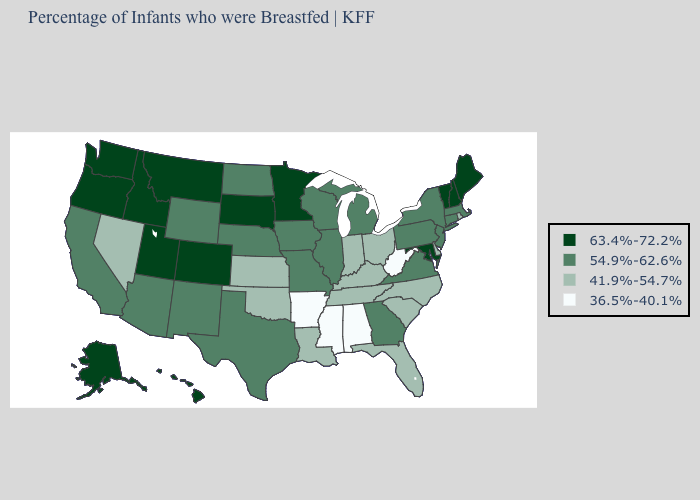Which states have the lowest value in the USA?
Concise answer only. Alabama, Arkansas, Mississippi, West Virginia. Does Pennsylvania have the lowest value in the USA?
Short answer required. No. What is the value of Pennsylvania?
Write a very short answer. 54.9%-62.6%. Does Texas have the lowest value in the USA?
Keep it brief. No. What is the value of Nebraska?
Quick response, please. 54.9%-62.6%. Which states have the highest value in the USA?
Quick response, please. Alaska, Colorado, Hawaii, Idaho, Maine, Maryland, Minnesota, Montana, New Hampshire, Oregon, South Dakota, Utah, Vermont, Washington. Does Florida have a lower value than Washington?
Write a very short answer. Yes. Among the states that border Georgia , does Alabama have the lowest value?
Give a very brief answer. Yes. Name the states that have a value in the range 36.5%-40.1%?
Quick response, please. Alabama, Arkansas, Mississippi, West Virginia. What is the value of Idaho?
Give a very brief answer. 63.4%-72.2%. Among the states that border Illinois , does Indiana have the lowest value?
Concise answer only. Yes. Among the states that border Indiana , which have the highest value?
Concise answer only. Illinois, Michigan. Which states hav the highest value in the Northeast?
Keep it brief. Maine, New Hampshire, Vermont. Among the states that border Mississippi , does Louisiana have the lowest value?
Write a very short answer. No. Name the states that have a value in the range 41.9%-54.7%?
Write a very short answer. Delaware, Florida, Indiana, Kansas, Kentucky, Louisiana, Nevada, North Carolina, Ohio, Oklahoma, Rhode Island, South Carolina, Tennessee. 